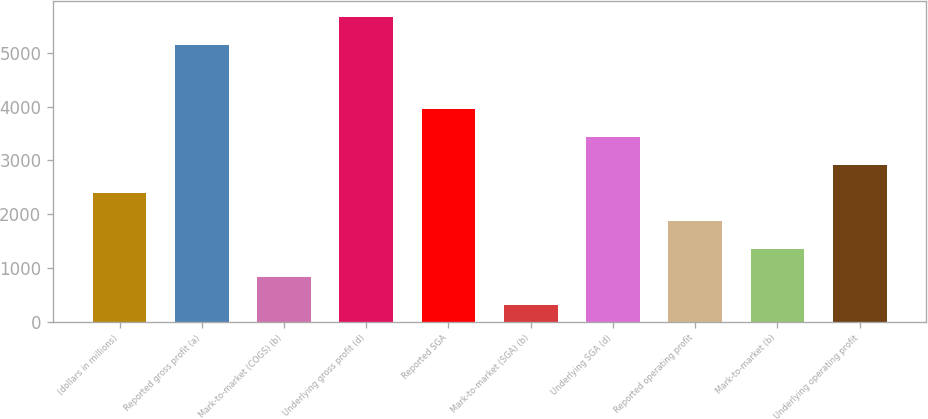<chart> <loc_0><loc_0><loc_500><loc_500><bar_chart><fcel>(dollars in millions)<fcel>Reported gross profit (a)<fcel>Mark-to-market (COGS) (b)<fcel>Underlying gross profit (d)<fcel>Reported SGA<fcel>Mark-to-market (SGA) (b)<fcel>Underlying SGA (d)<fcel>Reported operating profit<fcel>Mark-to-market (b)<fcel>Underlying operating profit<nl><fcel>2394.6<fcel>5152<fcel>827.4<fcel>5674.4<fcel>3961.8<fcel>305<fcel>3439.4<fcel>1872.2<fcel>1349.8<fcel>2917<nl></chart> 